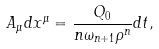<formula> <loc_0><loc_0><loc_500><loc_500>A _ { \mu } d x ^ { \mu } = \frac { Q _ { 0 } } { n \omega _ { n + 1 } \rho ^ { n } } d t ,</formula> 